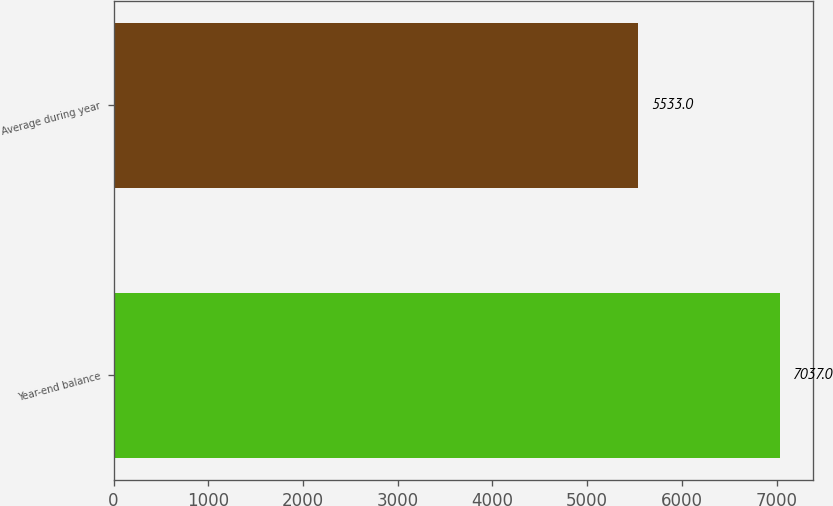Convert chart. <chart><loc_0><loc_0><loc_500><loc_500><bar_chart><fcel>Year-end balance<fcel>Average during year<nl><fcel>7037<fcel>5533<nl></chart> 